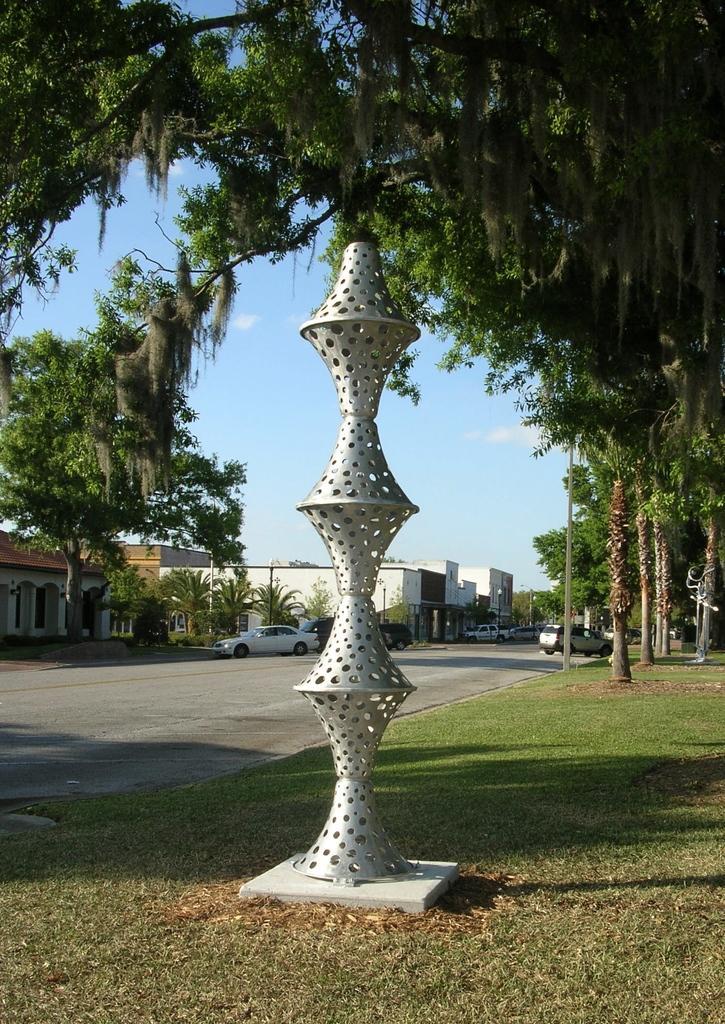Could you give a brief overview of what you see in this image? In this image I can see few building,trees,vehicles,poles and ash color pole. The sky is in blue and white color. 